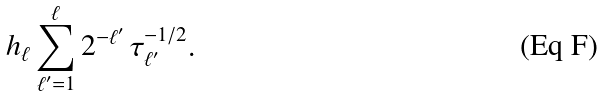<formula> <loc_0><loc_0><loc_500><loc_500>h _ { \ell } \sum _ { \ell ^ { \prime } = 1 } ^ { \ell } 2 ^ { - \ell ^ { \prime } } \, \tau _ { \ell ^ { \prime } } ^ { - 1 / 2 } .</formula> 